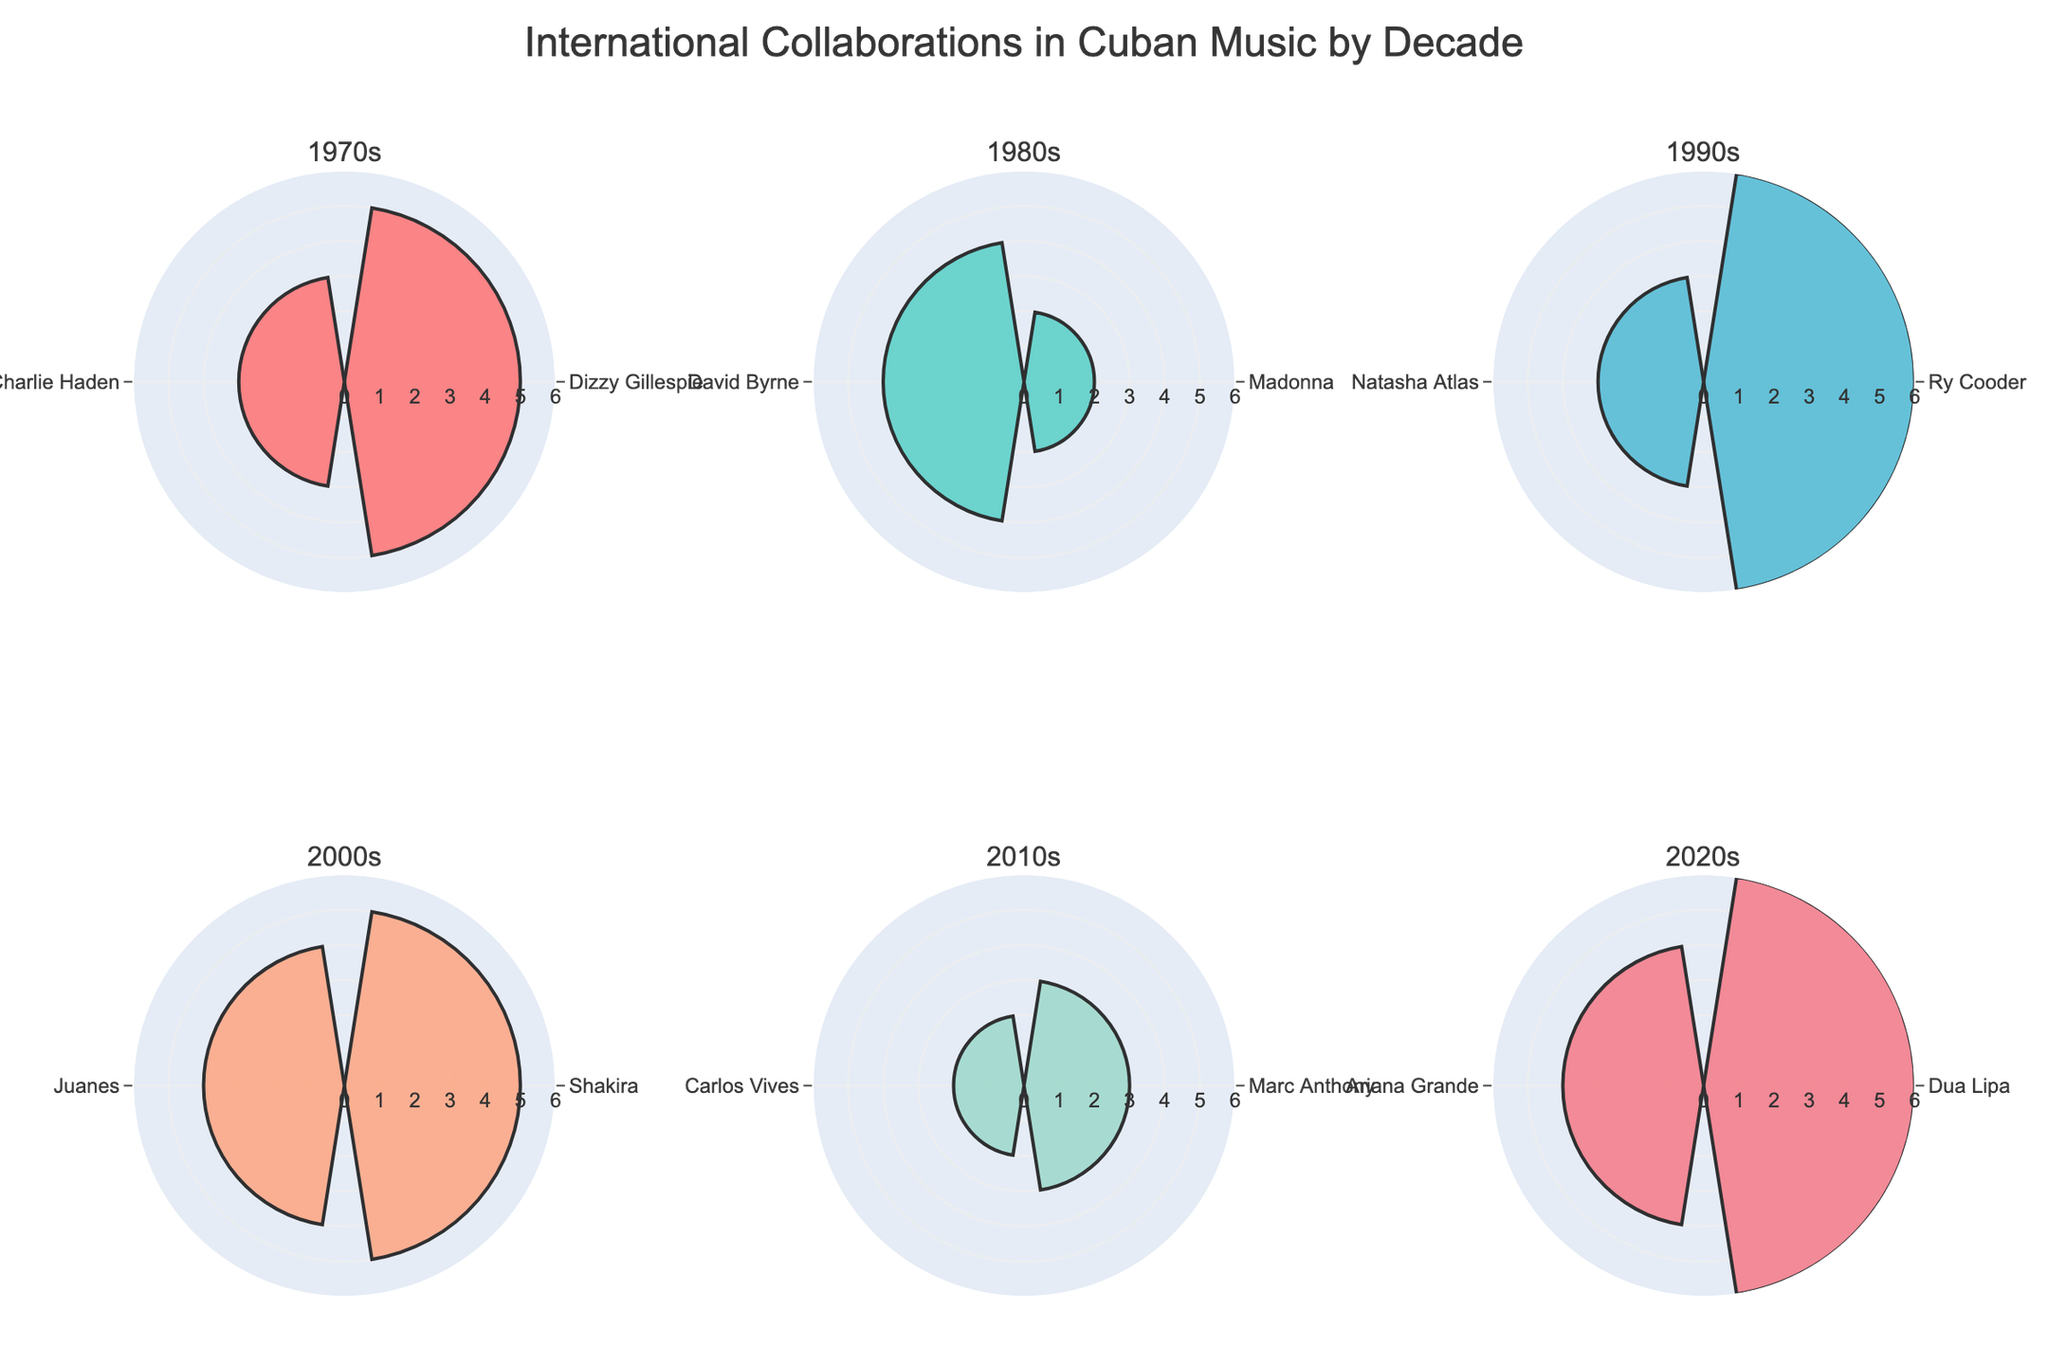Who collaborated with Cuban artists the most in the 2020s? To determine the most frequent collaborator in the 2020s, we look at the 2020s subplot and find the artist with the longest radial bar. Dua Lipa has the longest radial bar with 6 collaborations.
Answer: Dua Lipa Which decade had the highest total number of collaborations? To find the decade with the highest total number of collaborations, sum the collaboration counts for each decade and compare them. The counts are 8 for the 1970s, 6 for the 1980s, 9 for the 1990s, 9 for the 2000s, 5 for the 2010s, and 10 for the 2020s. The 2020s have the highest total.
Answer: 2020s How many collaborations did Shakira have in the 2000s? Examine the subplot for the 2000s and locate the radial bar for Shakira. The bar extends to a value of 5, indicating that Shakira had 5 collaborations in that decade.
Answer: 5 Which decades had exactly two artists with collaboration counts? Identify the subplots where exactly two radially oriented artist names appear. Both the 1980s and 2010s subplots show two artists each.
Answer: 1980s, 2010s Compare the number of collaborations between Marc Anthony and Carlos Vives in the 2010s. Who collaborated more? In the 2010s subplot, examine the radial bars for Marc Anthony and Carlos Vives. Marc Anthony's bar shows 3 collaborations, while Carlos Vives' bar shows 2. Therefore, Marc Anthony collaborated more.
Answer: Marc Anthony Which artist had the fewest collaborations in the 1990s, and what was the count? In the 1990s subplot, compare the radial bars. Natasha Atlas has the shortest bar with 3 collaborations, indicating she had the fewest.
Answer: Natasha Atlas, 3 What's the total number of collaborations in the dataset? Sum the respective collaboration counts from all decades. The counts are: 5+3 for 1970s, 2+4 for 1980s, 6+3 for 1990s, 5+4 for 2000s, 3+2 for 2010s, 6+4 for 2020s. Adding these up gives 5+3+2+4+6+3+5+4+3+2+6+4 = 47.
Answer: 47 In which decade did Ry Cooder collaborate, and how many collaborations did he have? Locate Ry Cooder in the subplots to see his decade and collaboration count. He appears in the 1990s subplot with a radial bar extending to 6 collaborations.
Answer: 1990s, 6 